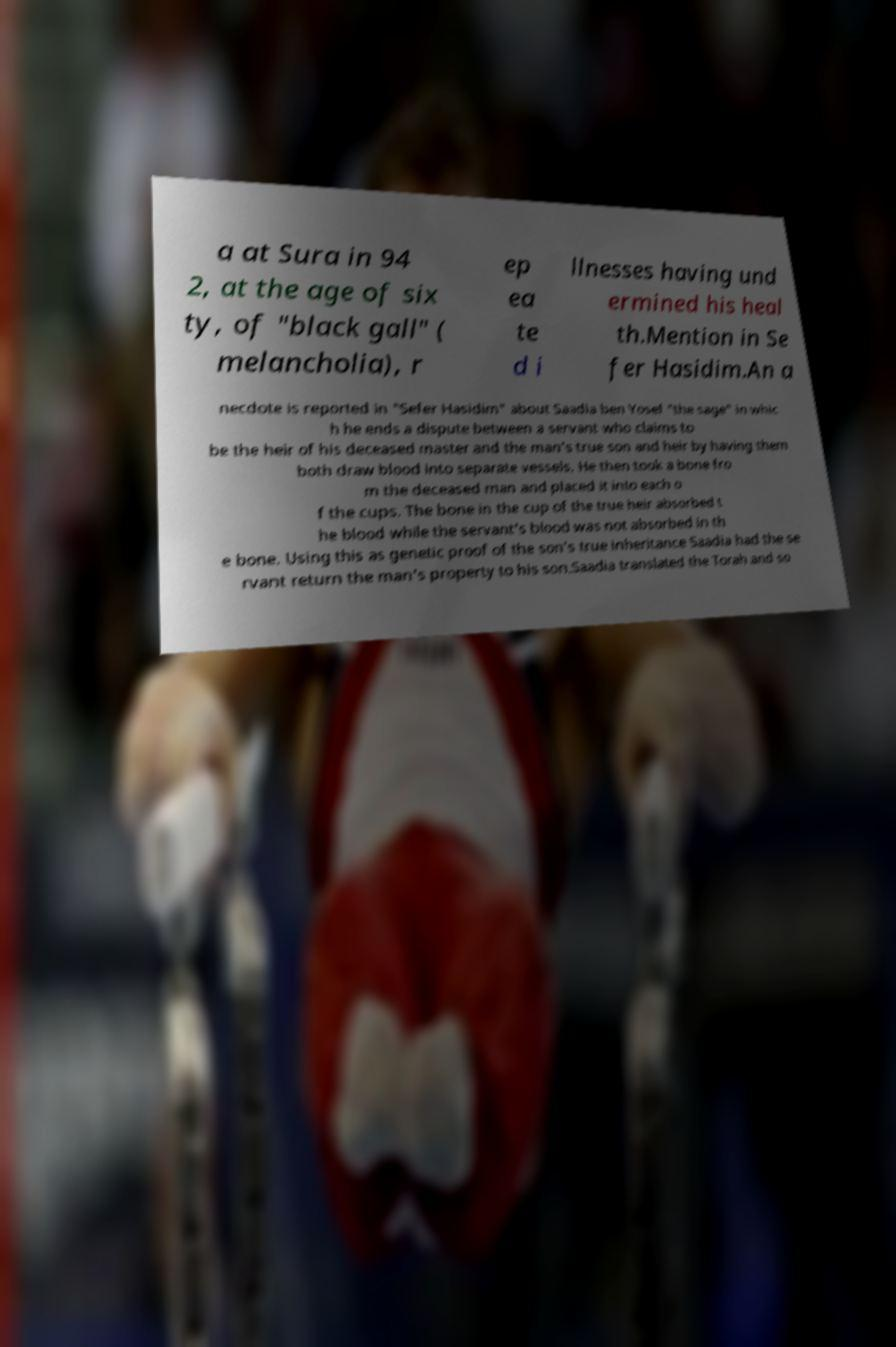Please read and relay the text visible in this image. What does it say? a at Sura in 94 2, at the age of six ty, of "black gall" ( melancholia), r ep ea te d i llnesses having und ermined his heal th.Mention in Se fer Hasidim.An a necdote is reported in "Sefer Hasidim" about Saadia ben Yosef "the sage" in whic h he ends a dispute between a servant who claims to be the heir of his deceased master and the man's true son and heir by having them both draw blood into separate vessels. He then took a bone fro m the deceased man and placed it into each o f the cups. The bone in the cup of the true heir absorbed t he blood while the servant's blood was not absorbed in th e bone. Using this as genetic proof of the son's true inheritance Saadia had the se rvant return the man's property to his son.Saadia translated the Torah and so 